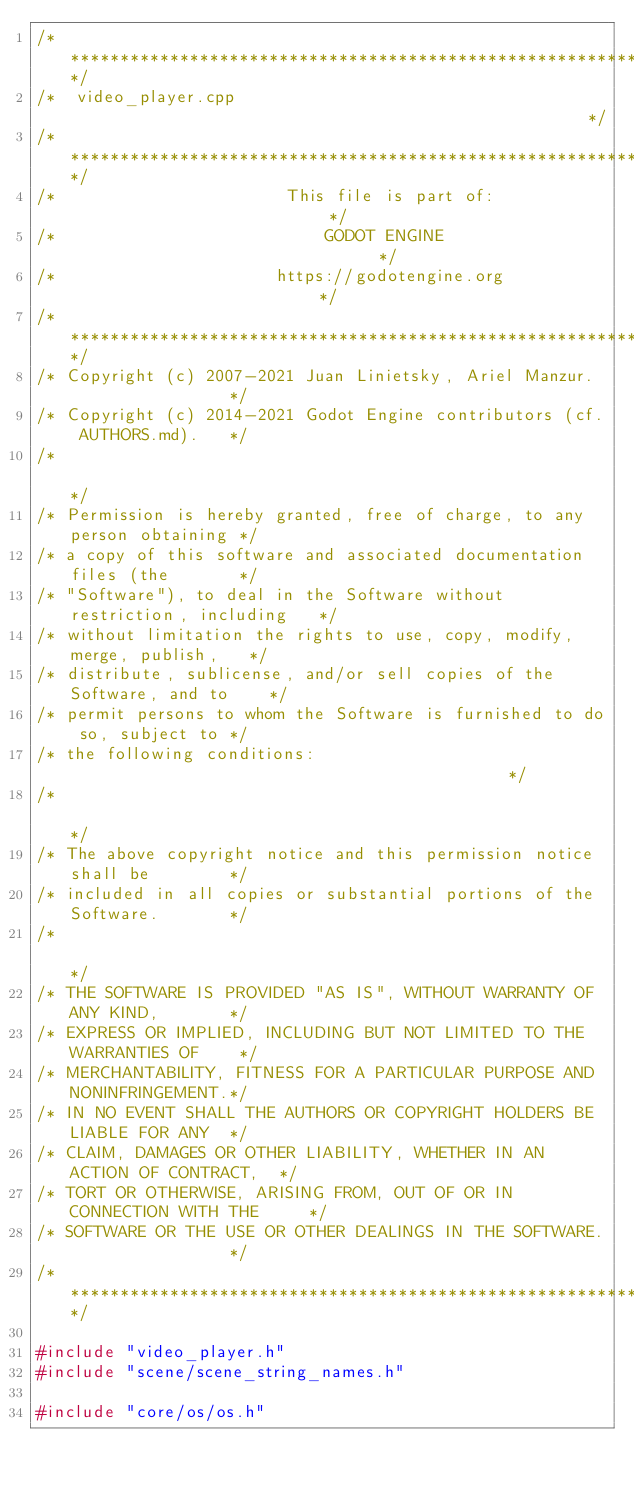Convert code to text. <code><loc_0><loc_0><loc_500><loc_500><_C++_>/*************************************************************************/
/*  video_player.cpp                                                     */
/*************************************************************************/
/*                       This file is part of:                           */
/*                           GODOT ENGINE                                */
/*                      https://godotengine.org                          */
/*************************************************************************/
/* Copyright (c) 2007-2021 Juan Linietsky, Ariel Manzur.                 */
/* Copyright (c) 2014-2021 Godot Engine contributors (cf. AUTHORS.md).   */
/*                                                                       */
/* Permission is hereby granted, free of charge, to any person obtaining */
/* a copy of this software and associated documentation files (the       */
/* "Software"), to deal in the Software without restriction, including   */
/* without limitation the rights to use, copy, modify, merge, publish,   */
/* distribute, sublicense, and/or sell copies of the Software, and to    */
/* permit persons to whom the Software is furnished to do so, subject to */
/* the following conditions:                                             */
/*                                                                       */
/* The above copyright notice and this permission notice shall be        */
/* included in all copies or substantial portions of the Software.       */
/*                                                                       */
/* THE SOFTWARE IS PROVIDED "AS IS", WITHOUT WARRANTY OF ANY KIND,       */
/* EXPRESS OR IMPLIED, INCLUDING BUT NOT LIMITED TO THE WARRANTIES OF    */
/* MERCHANTABILITY, FITNESS FOR A PARTICULAR PURPOSE AND NONINFRINGEMENT.*/
/* IN NO EVENT SHALL THE AUTHORS OR COPYRIGHT HOLDERS BE LIABLE FOR ANY  */
/* CLAIM, DAMAGES OR OTHER LIABILITY, WHETHER IN AN ACTION OF CONTRACT,  */
/* TORT OR OTHERWISE, ARISING FROM, OUT OF OR IN CONNECTION WITH THE     */
/* SOFTWARE OR THE USE OR OTHER DEALINGS IN THE SOFTWARE.                */
/*************************************************************************/

#include "video_player.h"
#include "scene/scene_string_names.h"

#include "core/os/os.h"</code> 